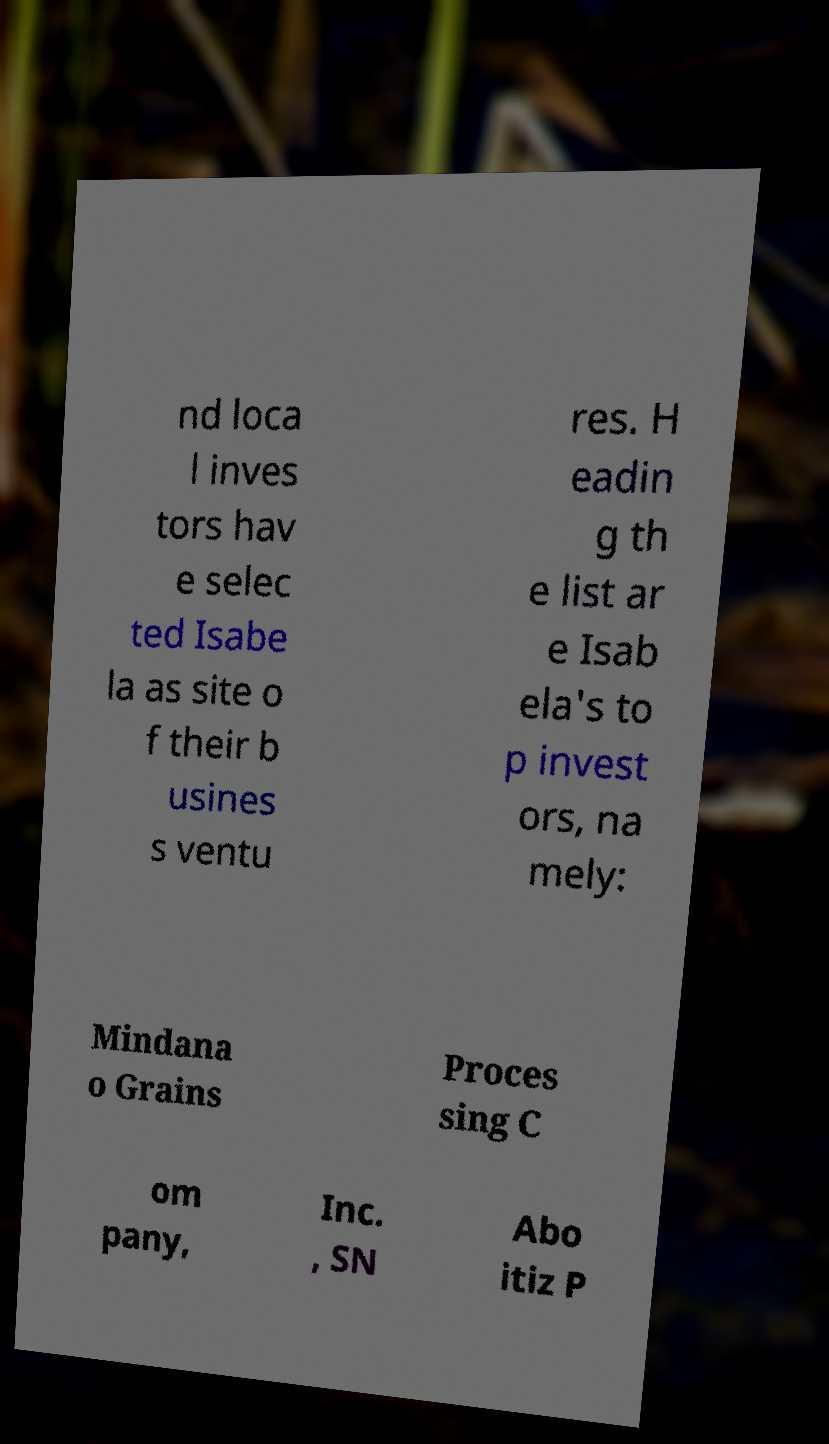What messages or text are displayed in this image? I need them in a readable, typed format. nd loca l inves tors hav e selec ted Isabe la as site o f their b usines s ventu res. H eadin g th e list ar e Isab ela's to p invest ors, na mely: Mindana o Grains Proces sing C om pany, Inc. , SN Abo itiz P 